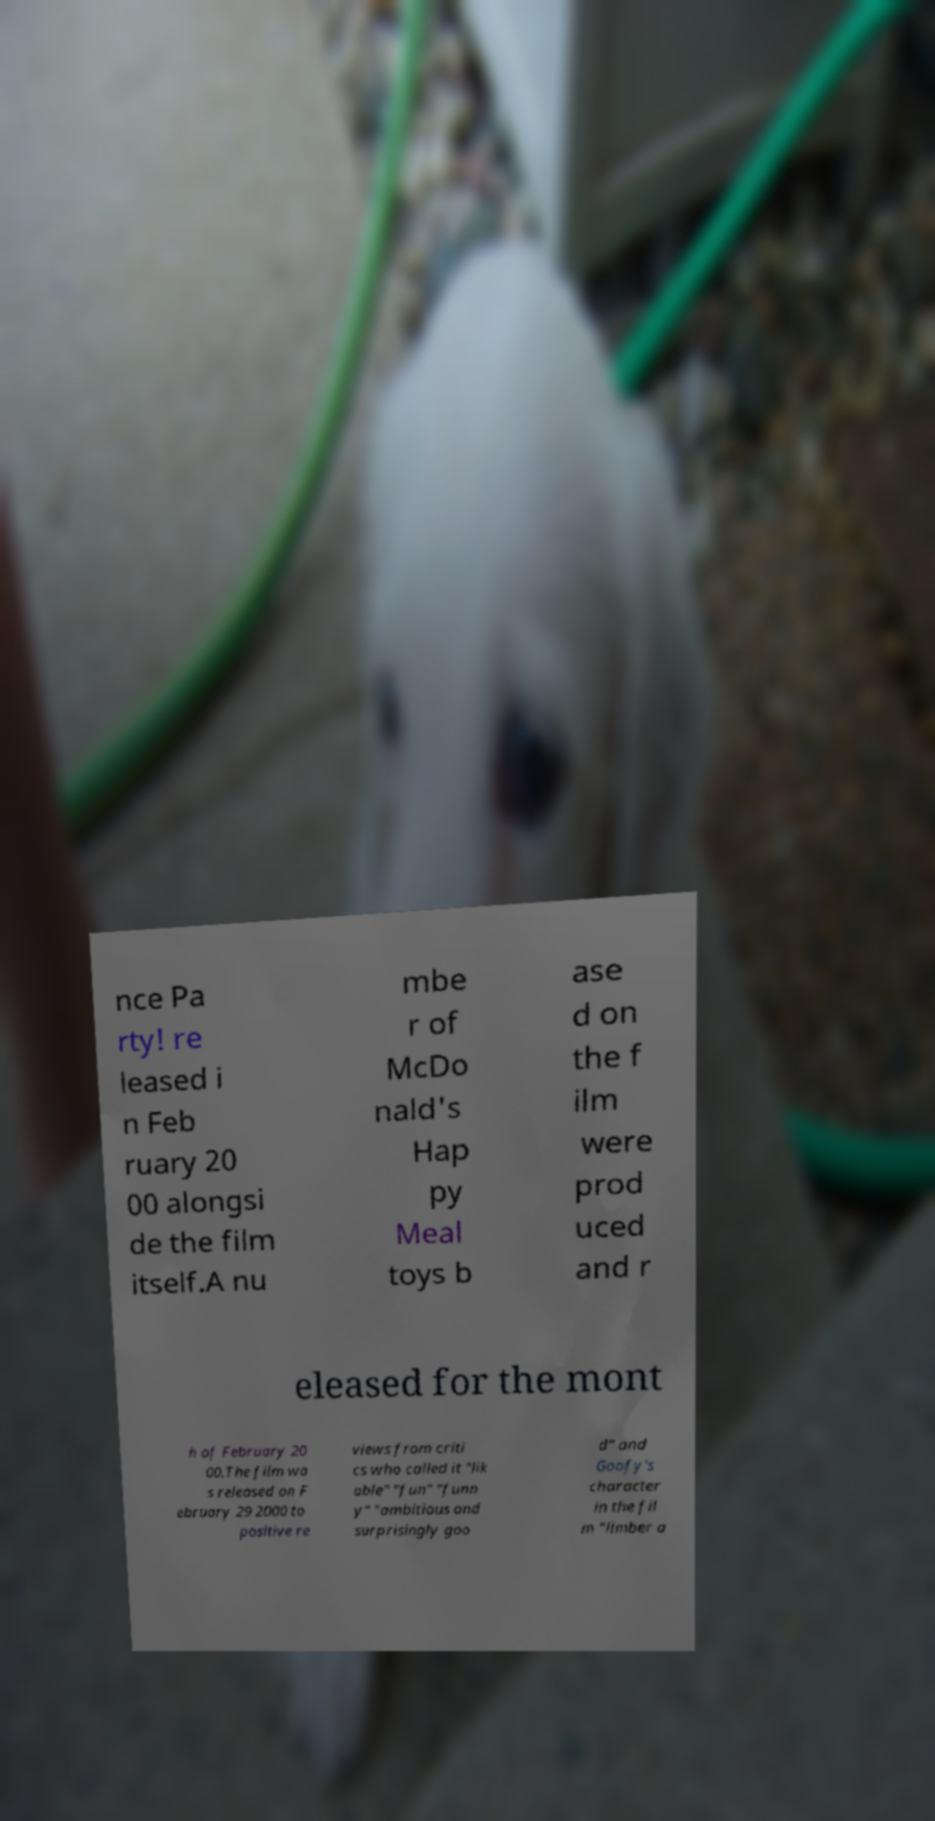For documentation purposes, I need the text within this image transcribed. Could you provide that? nce Pa rty! re leased i n Feb ruary 20 00 alongsi de the film itself.A nu mbe r of McDo nald's Hap py Meal toys b ase d on the f ilm were prod uced and r eleased for the mont h of February 20 00.The film wa s released on F ebruary 29 2000 to positive re views from criti cs who called it "lik able" "fun" "funn y" "ambitious and surprisingly goo d" and Goofy's character in the fil m "limber a 